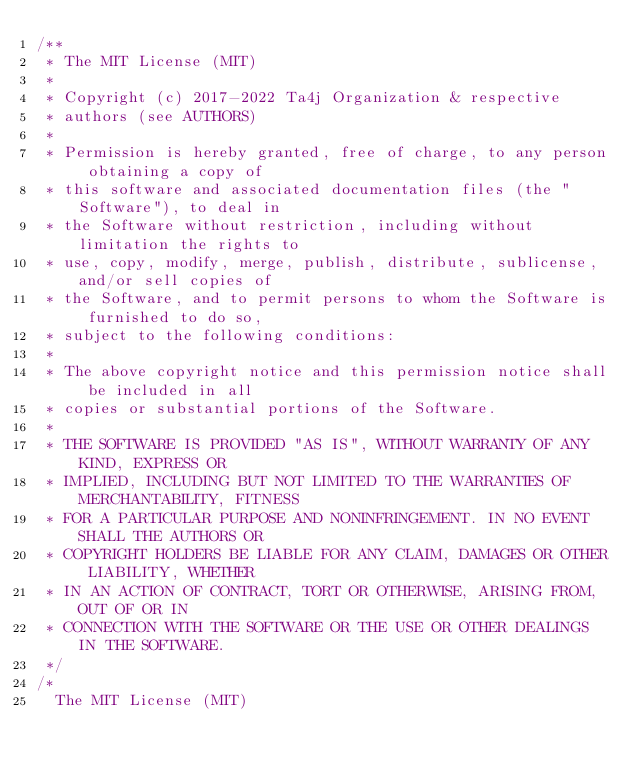Convert code to text. <code><loc_0><loc_0><loc_500><loc_500><_Java_>/**
 * The MIT License (MIT)
 *
 * Copyright (c) 2017-2022 Ta4j Organization & respective
 * authors (see AUTHORS)
 *
 * Permission is hereby granted, free of charge, to any person obtaining a copy of
 * this software and associated documentation files (the "Software"), to deal in
 * the Software without restriction, including without limitation the rights to
 * use, copy, modify, merge, publish, distribute, sublicense, and/or sell copies of
 * the Software, and to permit persons to whom the Software is furnished to do so,
 * subject to the following conditions:
 *
 * The above copyright notice and this permission notice shall be included in all
 * copies or substantial portions of the Software.
 *
 * THE SOFTWARE IS PROVIDED "AS IS", WITHOUT WARRANTY OF ANY KIND, EXPRESS OR
 * IMPLIED, INCLUDING BUT NOT LIMITED TO THE WARRANTIES OF MERCHANTABILITY, FITNESS
 * FOR A PARTICULAR PURPOSE AND NONINFRINGEMENT. IN NO EVENT SHALL THE AUTHORS OR
 * COPYRIGHT HOLDERS BE LIABLE FOR ANY CLAIM, DAMAGES OR OTHER LIABILITY, WHETHER
 * IN AN ACTION OF CONTRACT, TORT OR OTHERWISE, ARISING FROM, OUT OF OR IN
 * CONNECTION WITH THE SOFTWARE OR THE USE OR OTHER DEALINGS IN THE SOFTWARE.
 */
/*
  The MIT License (MIT)
</code> 